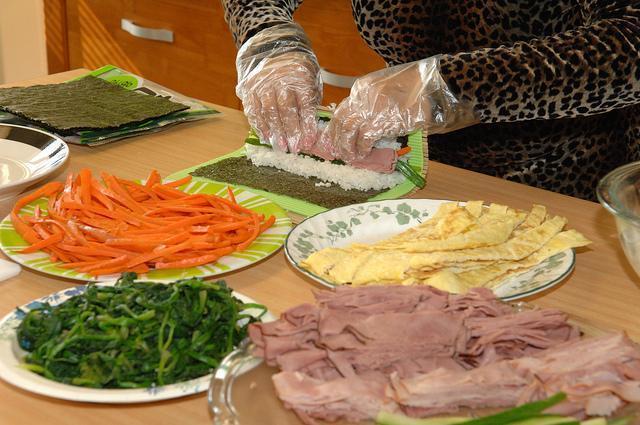Is the given caption "The broccoli is at the left side of the person." fitting for the image?
Answer yes or no. Yes. 